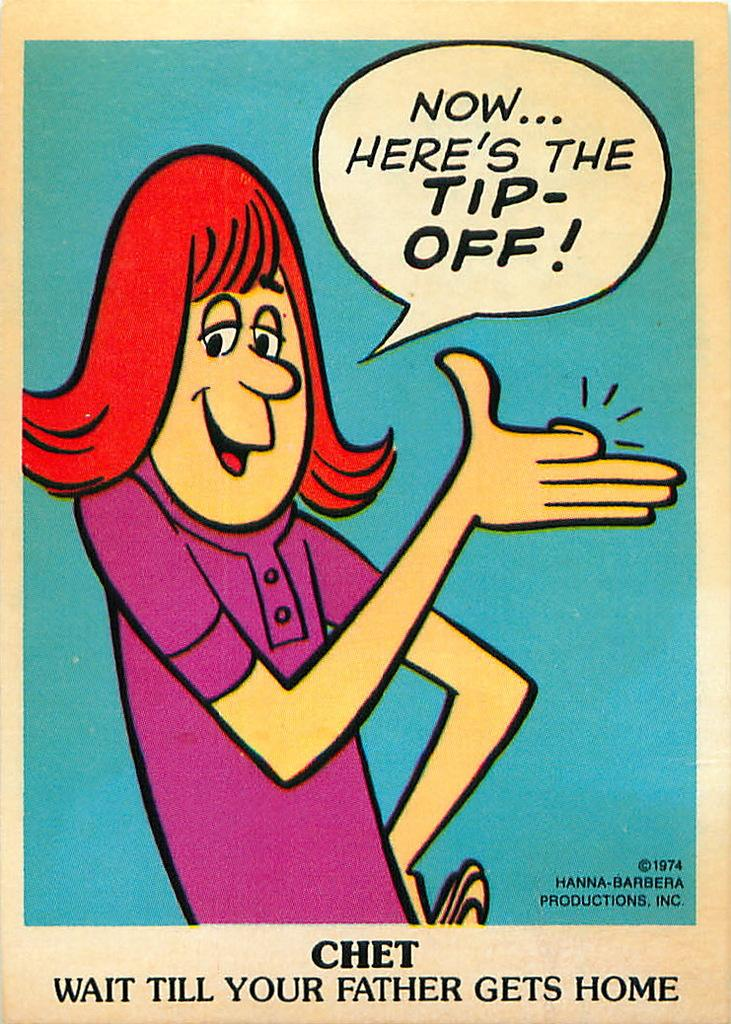Provide a one-sentence caption for the provided image. A women cartoon with red hair and a purple shirt saying Now... Here's the Tip-off. 